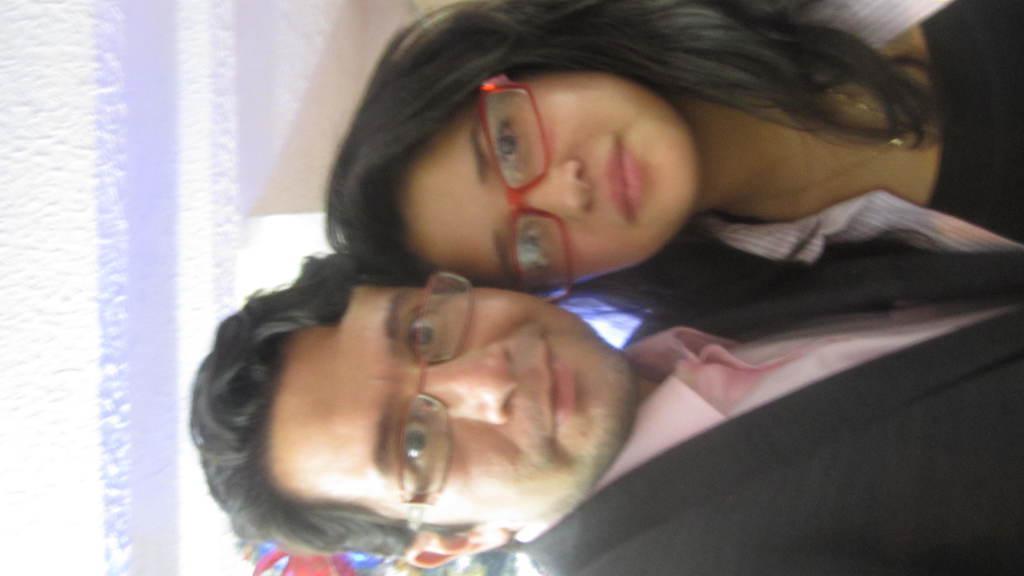Describe this image in one or two sentences. In this image we can see a man and a woman wearing the glasses. In the background we can see the wall. 